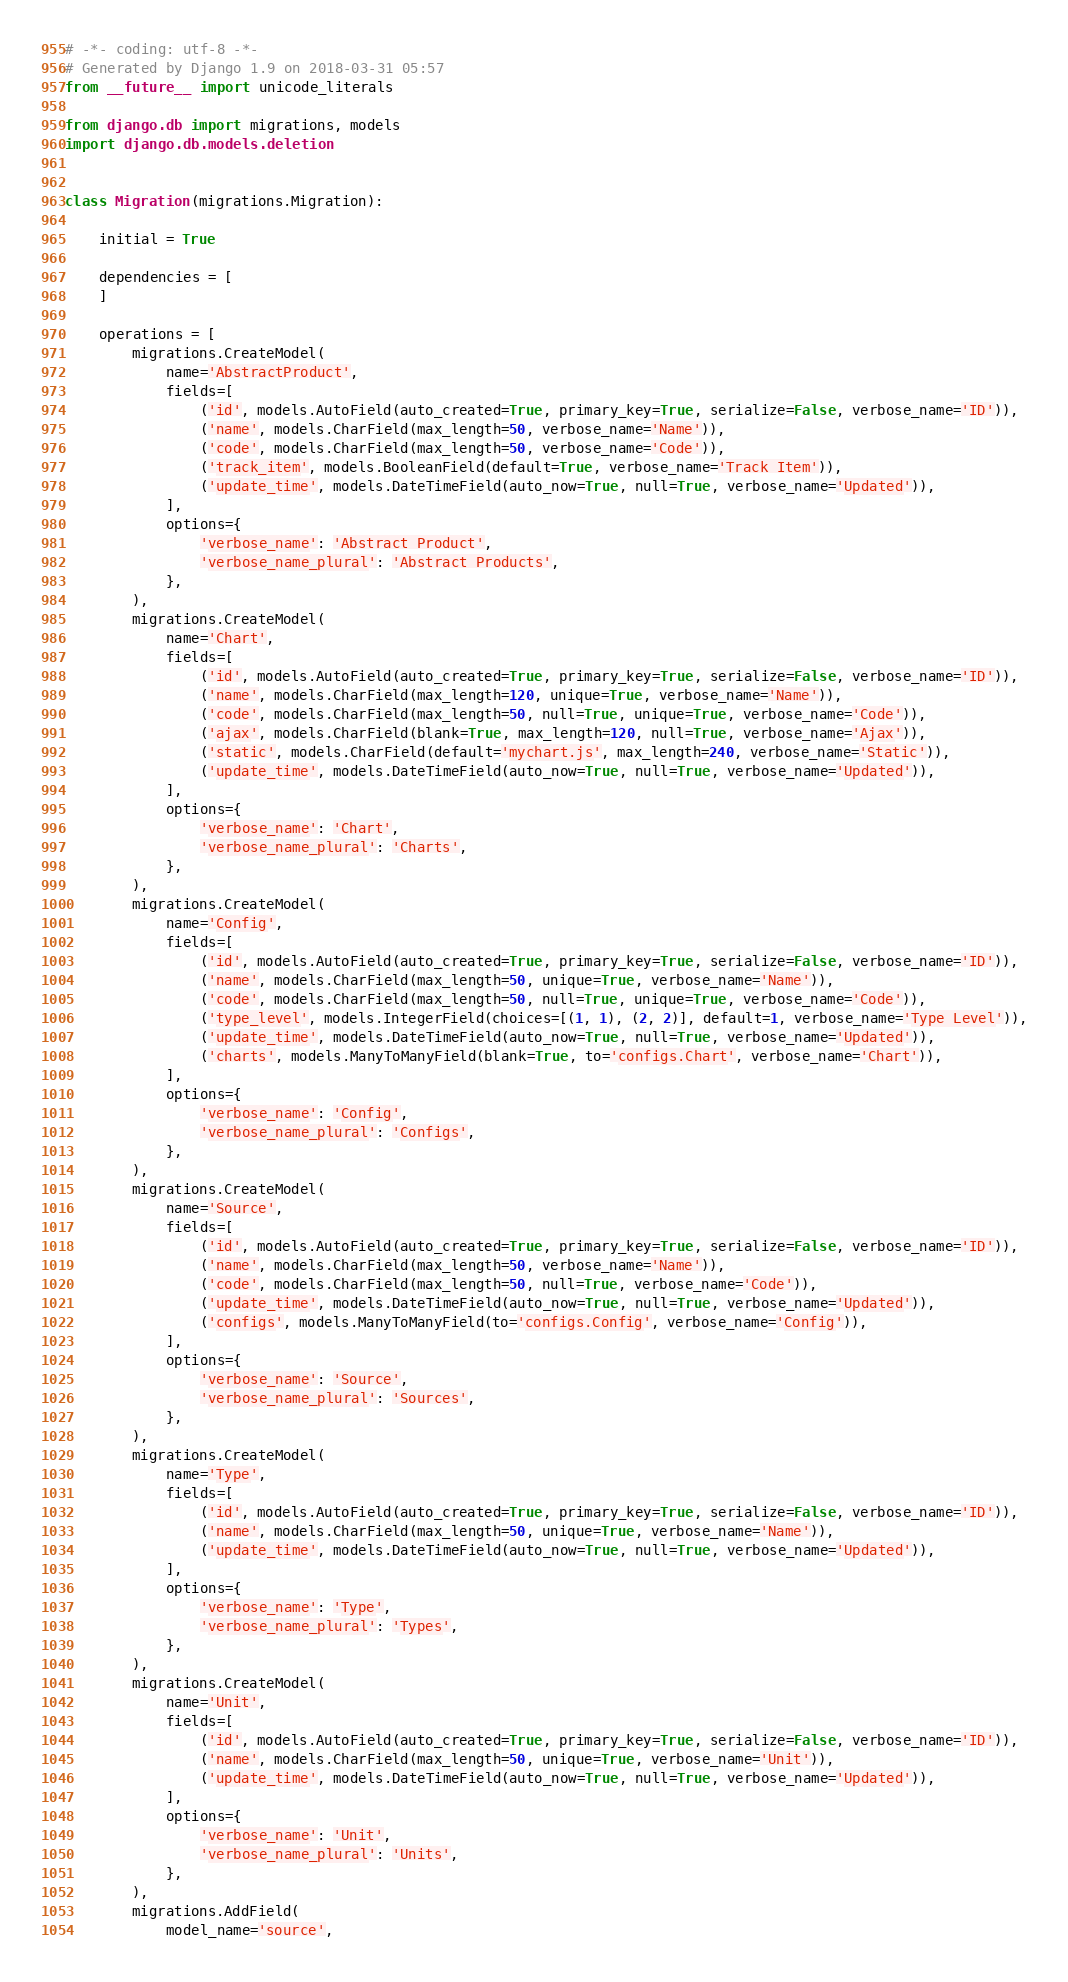<code> <loc_0><loc_0><loc_500><loc_500><_Python_># -*- coding: utf-8 -*-
# Generated by Django 1.9 on 2018-03-31 05:57
from __future__ import unicode_literals

from django.db import migrations, models
import django.db.models.deletion


class Migration(migrations.Migration):

    initial = True

    dependencies = [
    ]

    operations = [
        migrations.CreateModel(
            name='AbstractProduct',
            fields=[
                ('id', models.AutoField(auto_created=True, primary_key=True, serialize=False, verbose_name='ID')),
                ('name', models.CharField(max_length=50, verbose_name='Name')),
                ('code', models.CharField(max_length=50, verbose_name='Code')),
                ('track_item', models.BooleanField(default=True, verbose_name='Track Item')),
                ('update_time', models.DateTimeField(auto_now=True, null=True, verbose_name='Updated')),
            ],
            options={
                'verbose_name': 'Abstract Product',
                'verbose_name_plural': 'Abstract Products',
            },
        ),
        migrations.CreateModel(
            name='Chart',
            fields=[
                ('id', models.AutoField(auto_created=True, primary_key=True, serialize=False, verbose_name='ID')),
                ('name', models.CharField(max_length=120, unique=True, verbose_name='Name')),
                ('code', models.CharField(max_length=50, null=True, unique=True, verbose_name='Code')),
                ('ajax', models.CharField(blank=True, max_length=120, null=True, verbose_name='Ajax')),
                ('static', models.CharField(default='mychart.js', max_length=240, verbose_name='Static')),
                ('update_time', models.DateTimeField(auto_now=True, null=True, verbose_name='Updated')),
            ],
            options={
                'verbose_name': 'Chart',
                'verbose_name_plural': 'Charts',
            },
        ),
        migrations.CreateModel(
            name='Config',
            fields=[
                ('id', models.AutoField(auto_created=True, primary_key=True, serialize=False, verbose_name='ID')),
                ('name', models.CharField(max_length=50, unique=True, verbose_name='Name')),
                ('code', models.CharField(max_length=50, null=True, unique=True, verbose_name='Code')),
                ('type_level', models.IntegerField(choices=[(1, 1), (2, 2)], default=1, verbose_name='Type Level')),
                ('update_time', models.DateTimeField(auto_now=True, null=True, verbose_name='Updated')),
                ('charts', models.ManyToManyField(blank=True, to='configs.Chart', verbose_name='Chart')),
            ],
            options={
                'verbose_name': 'Config',
                'verbose_name_plural': 'Configs',
            },
        ),
        migrations.CreateModel(
            name='Source',
            fields=[
                ('id', models.AutoField(auto_created=True, primary_key=True, serialize=False, verbose_name='ID')),
                ('name', models.CharField(max_length=50, verbose_name='Name')),
                ('code', models.CharField(max_length=50, null=True, verbose_name='Code')),
                ('update_time', models.DateTimeField(auto_now=True, null=True, verbose_name='Updated')),
                ('configs', models.ManyToManyField(to='configs.Config', verbose_name='Config')),
            ],
            options={
                'verbose_name': 'Source',
                'verbose_name_plural': 'Sources',
            },
        ),
        migrations.CreateModel(
            name='Type',
            fields=[
                ('id', models.AutoField(auto_created=True, primary_key=True, serialize=False, verbose_name='ID')),
                ('name', models.CharField(max_length=50, unique=True, verbose_name='Name')),
                ('update_time', models.DateTimeField(auto_now=True, null=True, verbose_name='Updated')),
            ],
            options={
                'verbose_name': 'Type',
                'verbose_name_plural': 'Types',
            },
        ),
        migrations.CreateModel(
            name='Unit',
            fields=[
                ('id', models.AutoField(auto_created=True, primary_key=True, serialize=False, verbose_name='ID')),
                ('name', models.CharField(max_length=50, unique=True, verbose_name='Unit')),
                ('update_time', models.DateTimeField(auto_now=True, null=True, verbose_name='Updated')),
            ],
            options={
                'verbose_name': 'Unit',
                'verbose_name_plural': 'Units',
            },
        ),
        migrations.AddField(
            model_name='source',</code> 